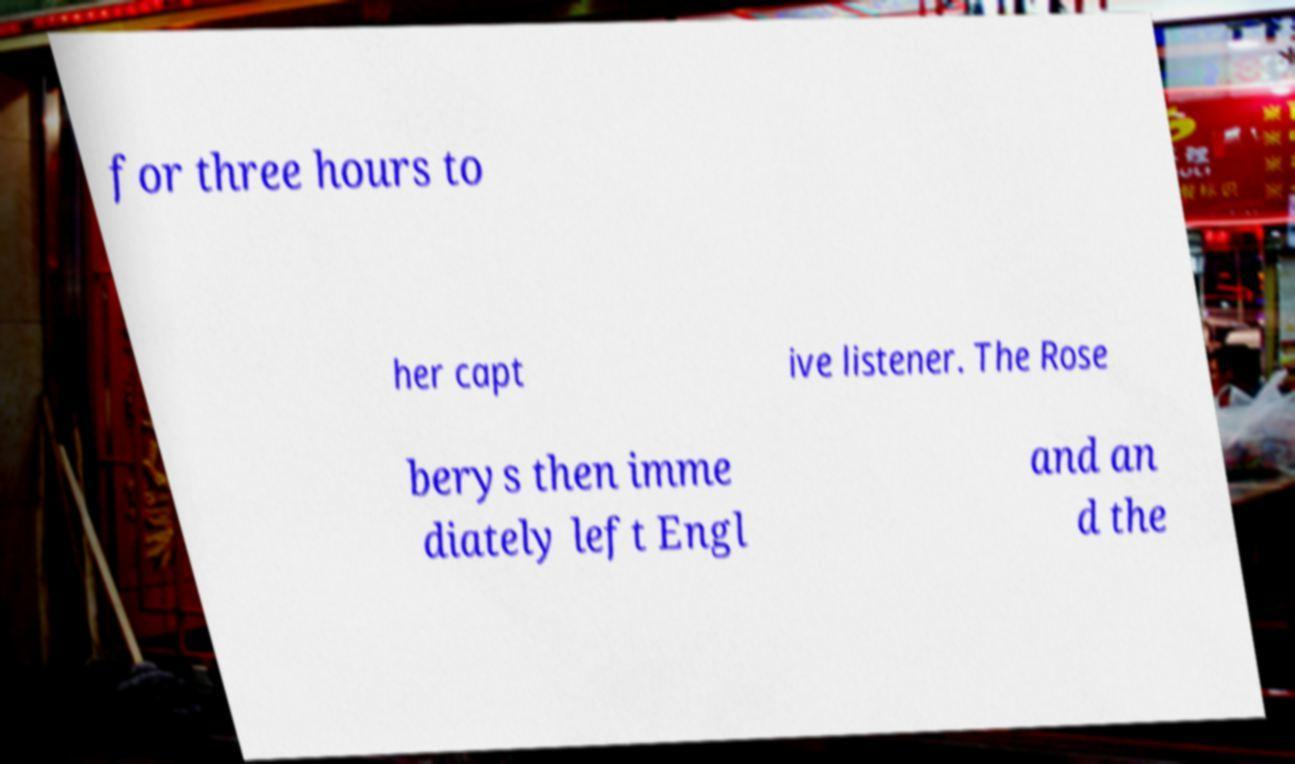I need the written content from this picture converted into text. Can you do that? for three hours to her capt ive listener. The Rose berys then imme diately left Engl and an d the 